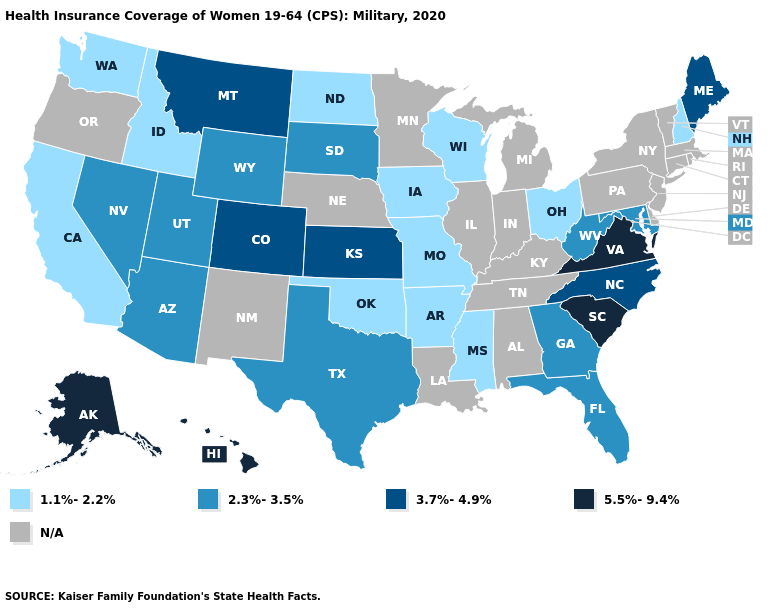Name the states that have a value in the range 3.7%-4.9%?
Be succinct. Colorado, Kansas, Maine, Montana, North Carolina. Is the legend a continuous bar?
Quick response, please. No. Which states have the highest value in the USA?
Short answer required. Alaska, Hawaii, South Carolina, Virginia. Does the first symbol in the legend represent the smallest category?
Answer briefly. Yes. Which states have the lowest value in the USA?
Write a very short answer. Arkansas, California, Idaho, Iowa, Mississippi, Missouri, New Hampshire, North Dakota, Ohio, Oklahoma, Washington, Wisconsin. Name the states that have a value in the range 5.5%-9.4%?
Concise answer only. Alaska, Hawaii, South Carolina, Virginia. Name the states that have a value in the range 2.3%-3.5%?
Be succinct. Arizona, Florida, Georgia, Maryland, Nevada, South Dakota, Texas, Utah, West Virginia, Wyoming. What is the value of Florida?
Answer briefly. 2.3%-3.5%. Among the states that border North Carolina , does South Carolina have the highest value?
Be succinct. Yes. What is the value of Vermont?
Keep it brief. N/A. What is the value of Vermont?
Write a very short answer. N/A. Among the states that border Georgia , does South Carolina have the highest value?
Answer briefly. Yes. Which states have the lowest value in the MidWest?
Answer briefly. Iowa, Missouri, North Dakota, Ohio, Wisconsin. What is the value of Wyoming?
Short answer required. 2.3%-3.5%. What is the value of Wisconsin?
Answer briefly. 1.1%-2.2%. 